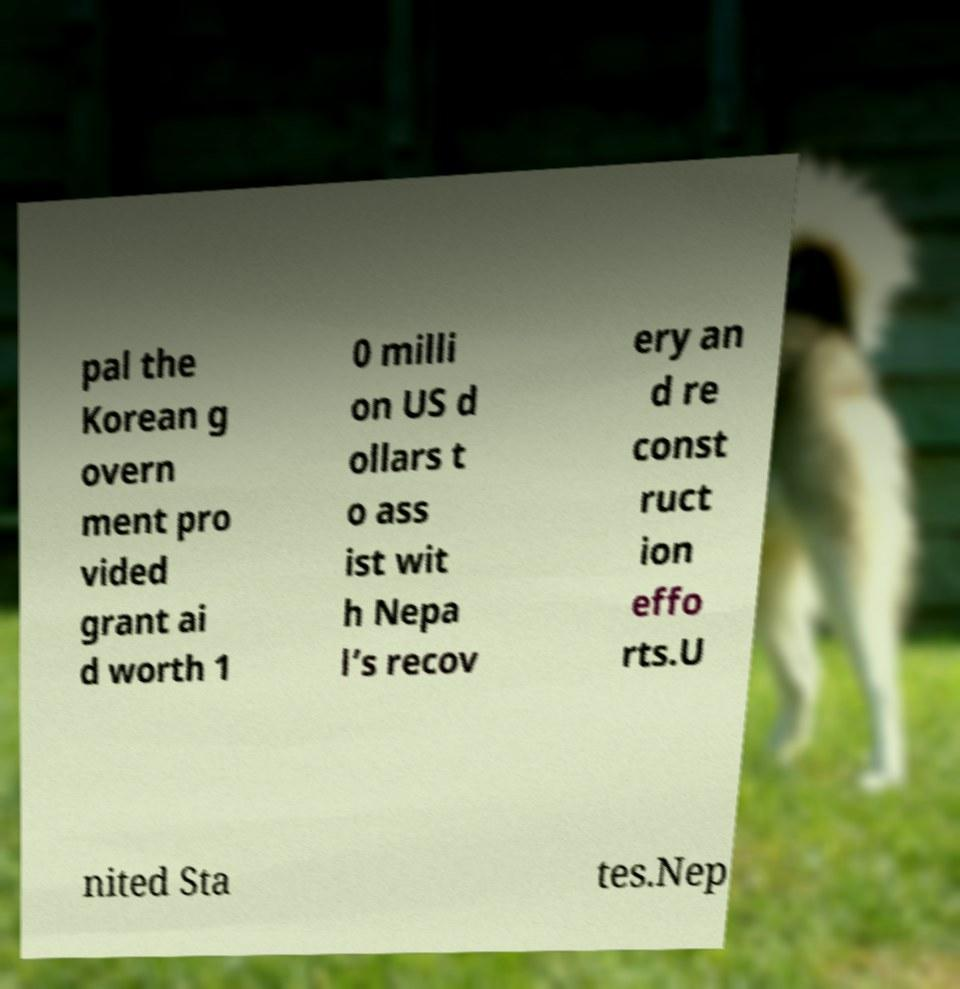What messages or text are displayed in this image? I need them in a readable, typed format. pal the Korean g overn ment pro vided grant ai d worth 1 0 milli on US d ollars t o ass ist wit h Nepa l’s recov ery an d re const ruct ion effo rts.U nited Sta tes.Nep 